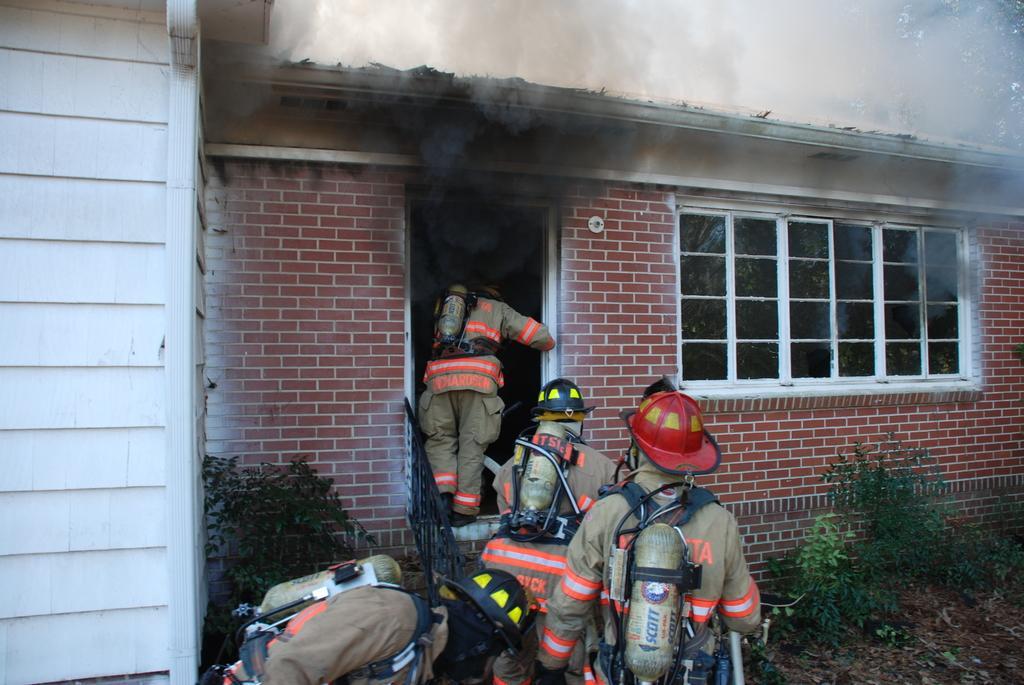Describe this image in one or two sentences. In this image there are people with cylinders, there is grass, plants, house, smoke coming from the house ,tree. 